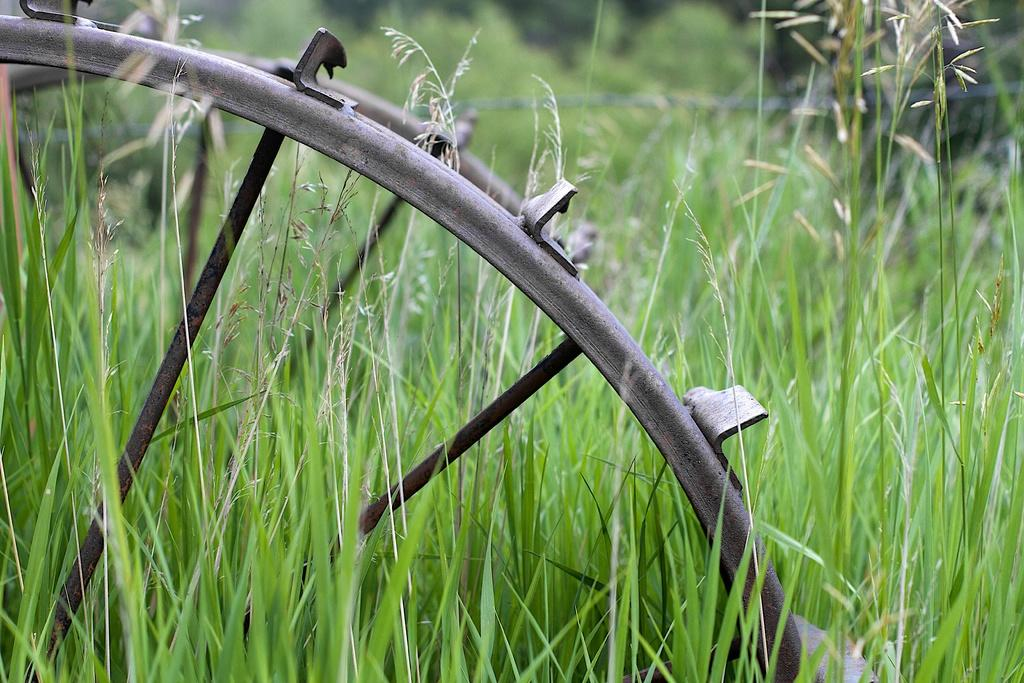What type of object is made of metal in the image? There is a metal object in the image. What colors are present on the metal object? The metal object is grey and black in color. What type of living organisms can be seen in the image? There are plants in the image. What colors are present on the plants? The plants are green and cream in color. How would you describe the background of the image? The background of the image is blurry. What type of crayon can be seen melting on the cup in the image? There is no crayon or cup present in the image. What type of leaf is visible on the plant in the image? There is no specific leaf mentioned in the image; only the colors of the plants are described. 